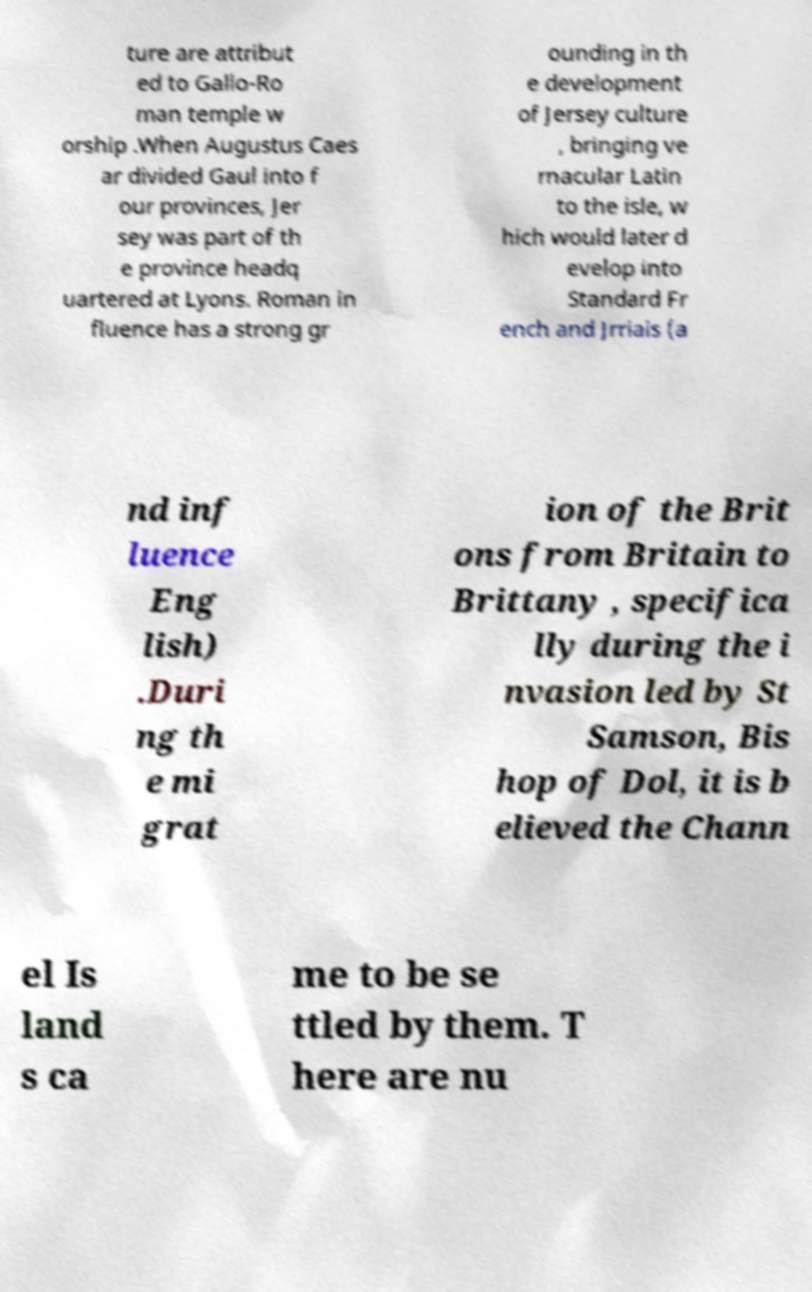Please identify and transcribe the text found in this image. ture are attribut ed to Gallo-Ro man temple w orship .When Augustus Caes ar divided Gaul into f our provinces, Jer sey was part of th e province headq uartered at Lyons. Roman in fluence has a strong gr ounding in th e development of Jersey culture , bringing ve rnacular Latin to the isle, w hich would later d evelop into Standard Fr ench and Jrriais (a nd inf luence Eng lish) .Duri ng th e mi grat ion of the Brit ons from Britain to Brittany , specifica lly during the i nvasion led by St Samson, Bis hop of Dol, it is b elieved the Chann el Is land s ca me to be se ttled by them. T here are nu 